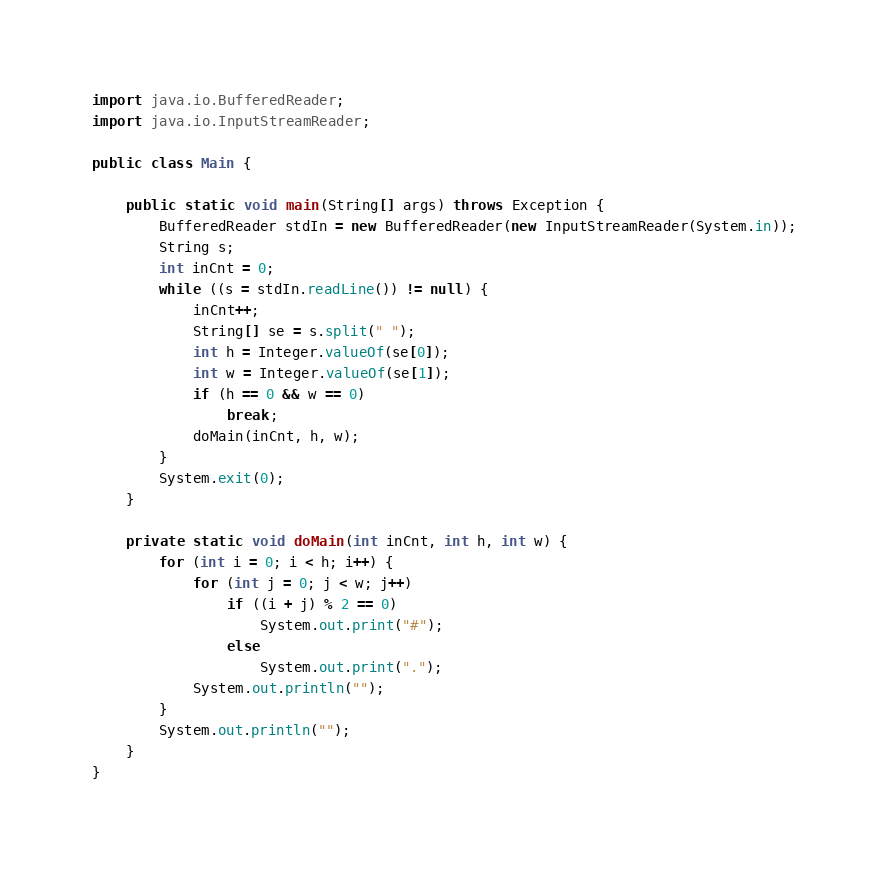Convert code to text. <code><loc_0><loc_0><loc_500><loc_500><_Java_>import java.io.BufferedReader;
import java.io.InputStreamReader;

public class Main {

	public static void main(String[] args) throws Exception {
		BufferedReader stdIn = new BufferedReader(new InputStreamReader(System.in));
		String s;
		int inCnt = 0;
		while ((s = stdIn.readLine()) != null) {
			inCnt++;
			String[] se = s.split(" ");
			int h = Integer.valueOf(se[0]);
			int w = Integer.valueOf(se[1]);
			if (h == 0 && w == 0)
				break;
			doMain(inCnt, h, w);
		}
		System.exit(0);
	}

	private static void doMain(int inCnt, int h, int w) {
		for (int i = 0; i < h; i++) {
			for (int j = 0; j < w; j++)
				if ((i + j) % 2 == 0)
					System.out.print("#");
				else
					System.out.print(".");
			System.out.println("");
		}
		System.out.println("");
	}
}</code> 